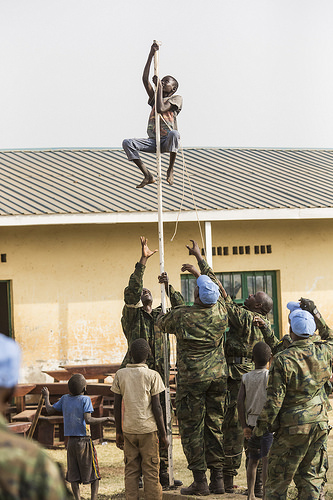<image>
Is the building behind the pole? Yes. From this viewpoint, the building is positioned behind the pole, with the pole partially or fully occluding the building. 